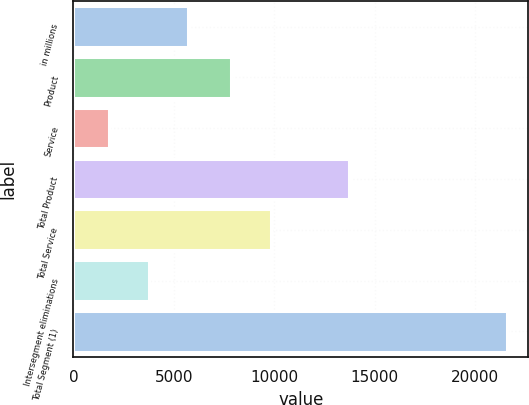Convert chart to OTSL. <chart><loc_0><loc_0><loc_500><loc_500><bar_chart><fcel>in millions<fcel>Product<fcel>Service<fcel>Total Product<fcel>Total Service<fcel>Intersegment eliminations<fcel>Total Segment (1)<nl><fcel>5718.6<fcel>7837<fcel>1755<fcel>13717<fcel>9818.8<fcel>3736.8<fcel>21573<nl></chart> 